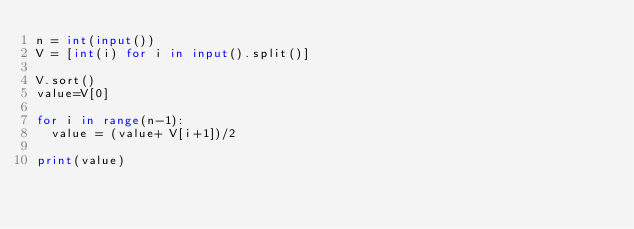Convert code to text. <code><loc_0><loc_0><loc_500><loc_500><_Python_>n = int(input())
V = [int(i) for i in input().split()]

V.sort()
value=V[0]

for i in range(n-1):
  value = (value+ V[i+1])/2

print(value)</code> 